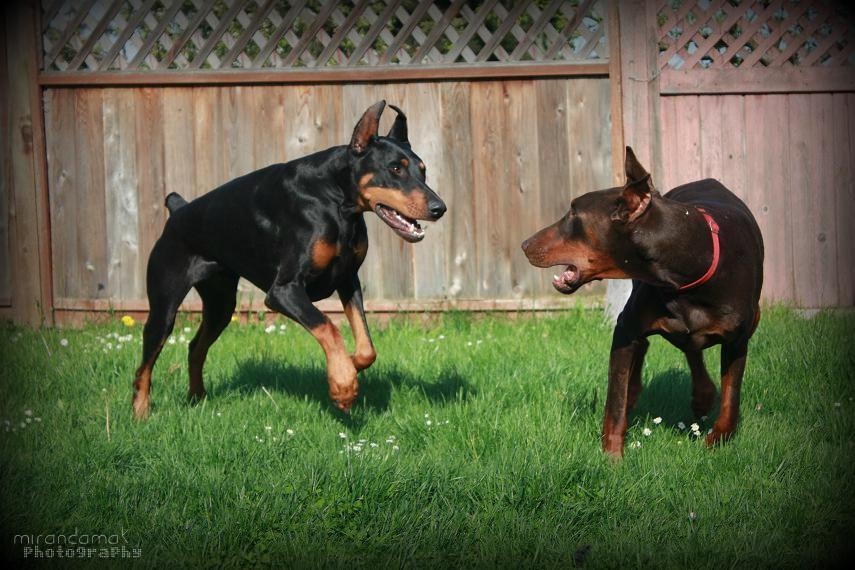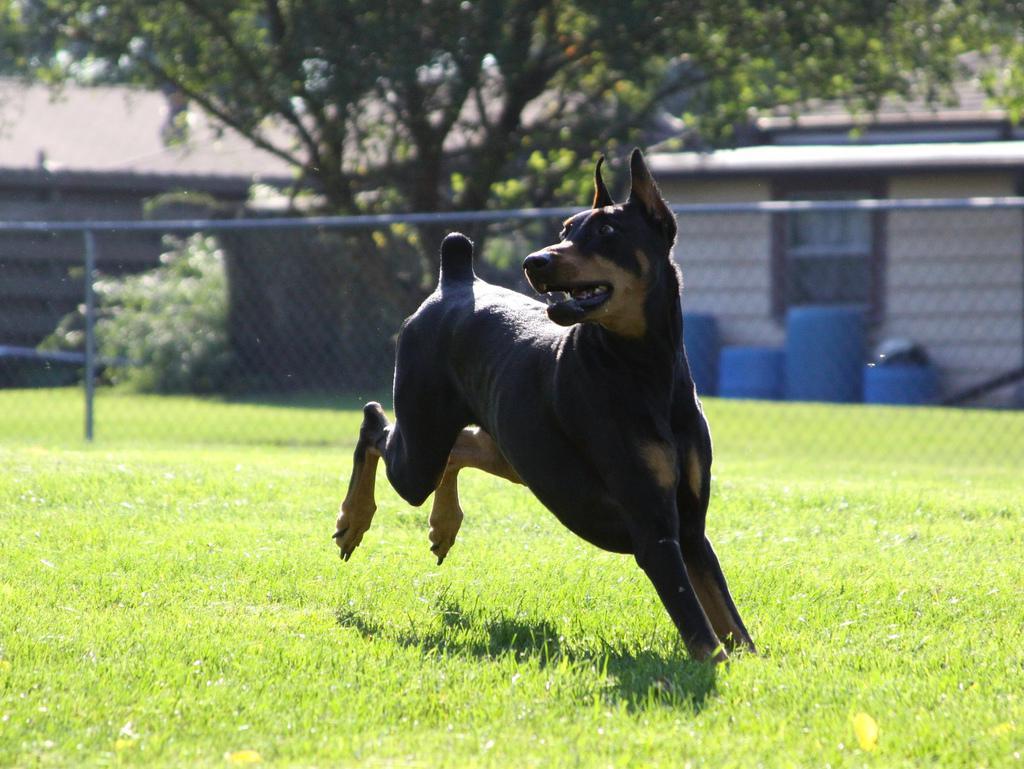The first image is the image on the left, the second image is the image on the right. Examine the images to the left and right. Is the description "The right image contains exactly two dogs." accurate? Answer yes or no. No. The first image is the image on the left, the second image is the image on the right. Examine the images to the left and right. Is the description "Each image shows two dogs of similar size interacting in close proximity." accurate? Answer yes or no. No. 